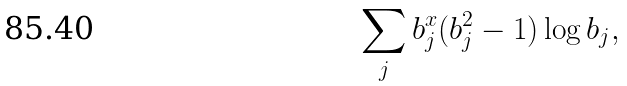<formula> <loc_0><loc_0><loc_500><loc_500>\sum _ { j } b _ { j } ^ { x } ( b _ { j } ^ { 2 } - 1 ) \log b _ { j } ,</formula> 